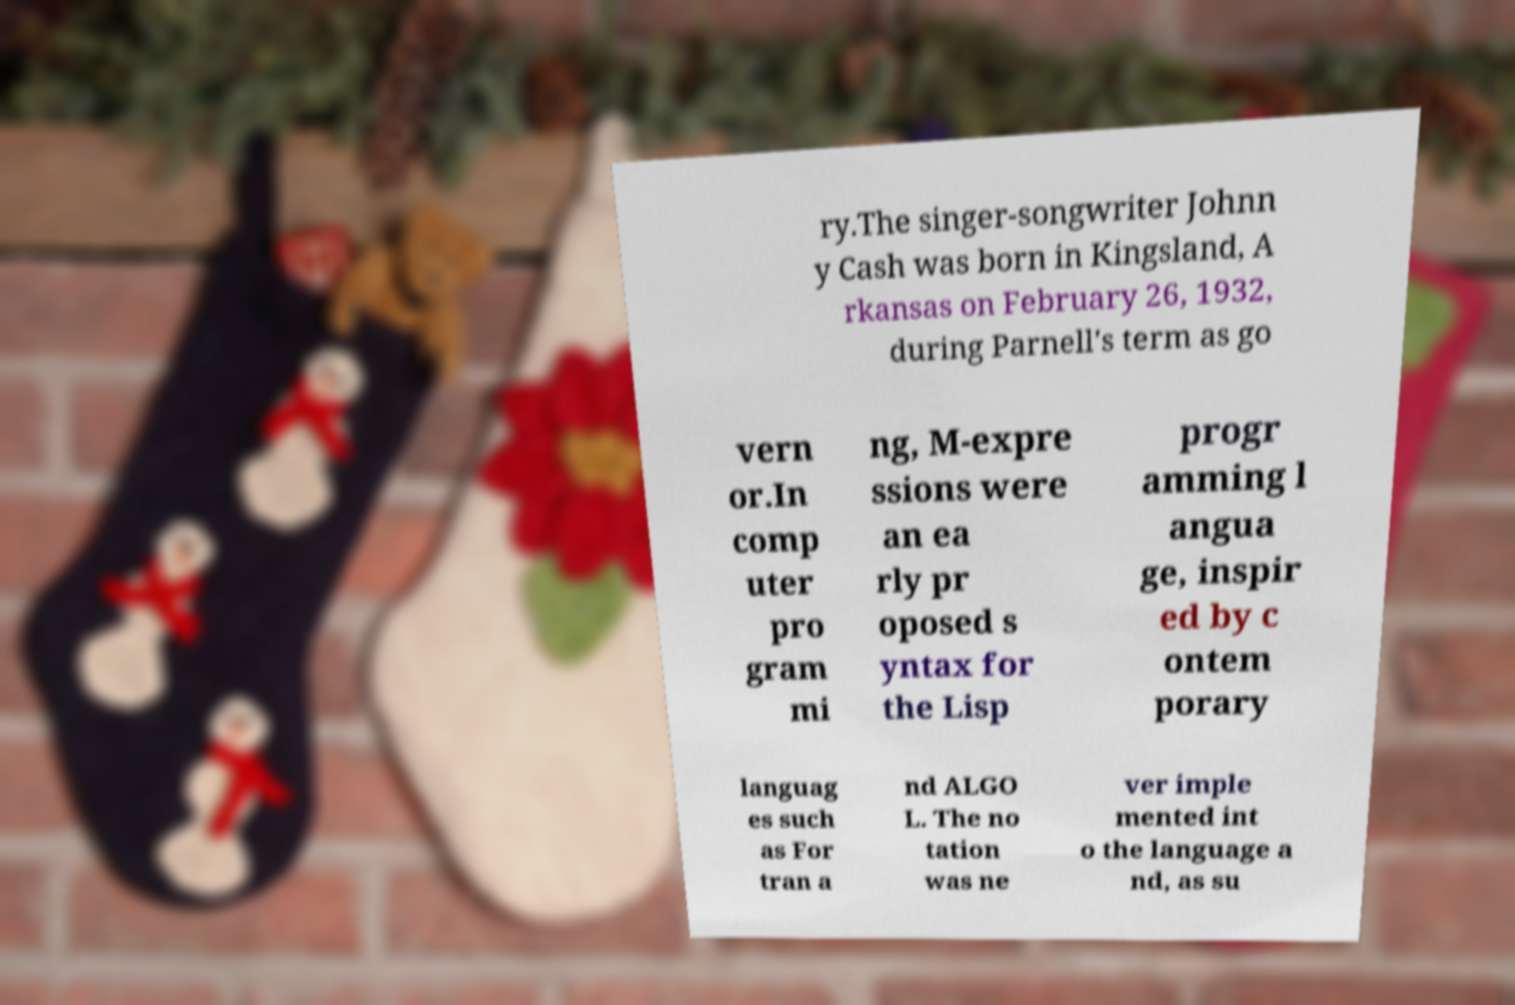Please read and relay the text visible in this image. What does it say? ry.The singer-songwriter Johnn y Cash was born in Kingsland, A rkansas on February 26, 1932, during Parnell's term as go vern or.In comp uter pro gram mi ng, M-expre ssions were an ea rly pr oposed s yntax for the Lisp progr amming l angua ge, inspir ed by c ontem porary languag es such as For tran a nd ALGO L. The no tation was ne ver imple mented int o the language a nd, as su 